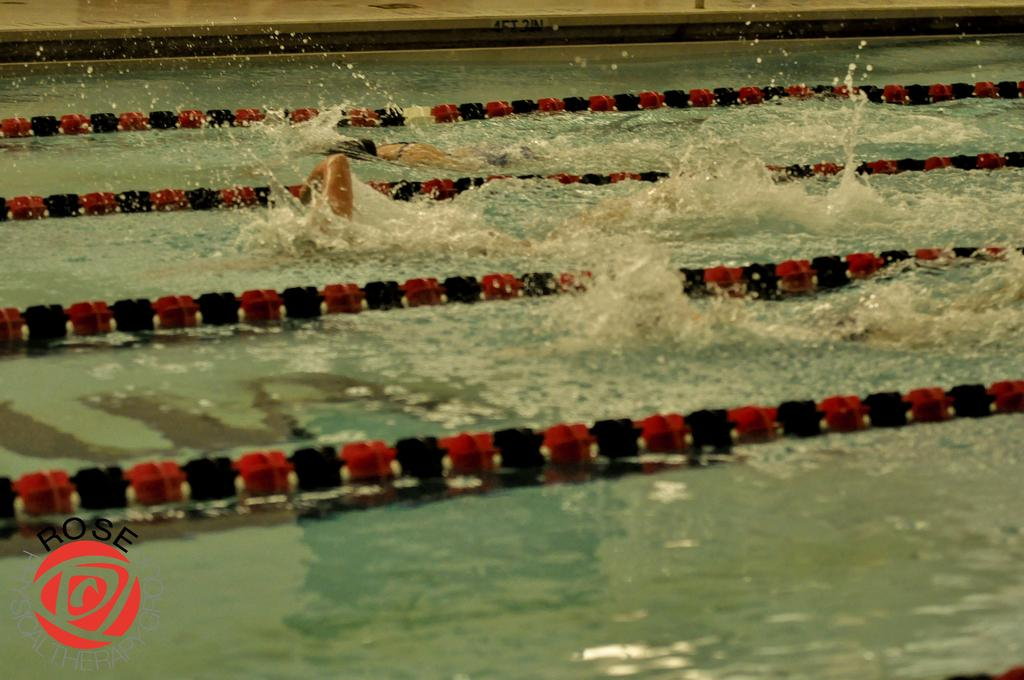What are the people in the image doing? The people in the image are swimming in the water. What else can be seen on the water besides the swimmers? There are objects on the water. What is visible at the top of the image? The top of the image contains a floor. What can be found in the left bottom of the image? There is a logo and some text in the left bottom of the image. Can you see any deer playing basketball on the floor in the image? No, there are no deer or basketball in the image; it features people swimming in the water and objects on the water. 